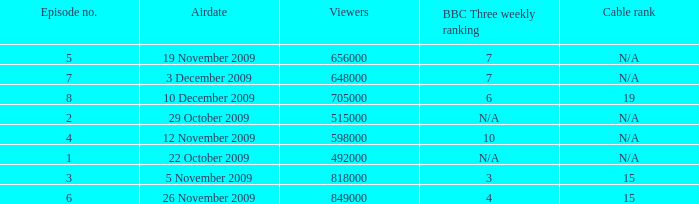What is the cable rank for bbc three weekly ranking of n/a? N/A, N/A. 